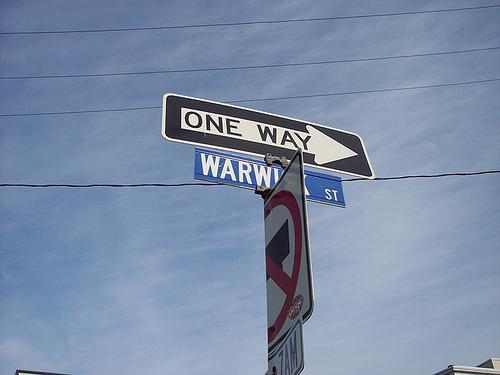How many cables can you see?
Give a very brief answer. 4. How many colors are the signs?
Give a very brief answer. 4. 